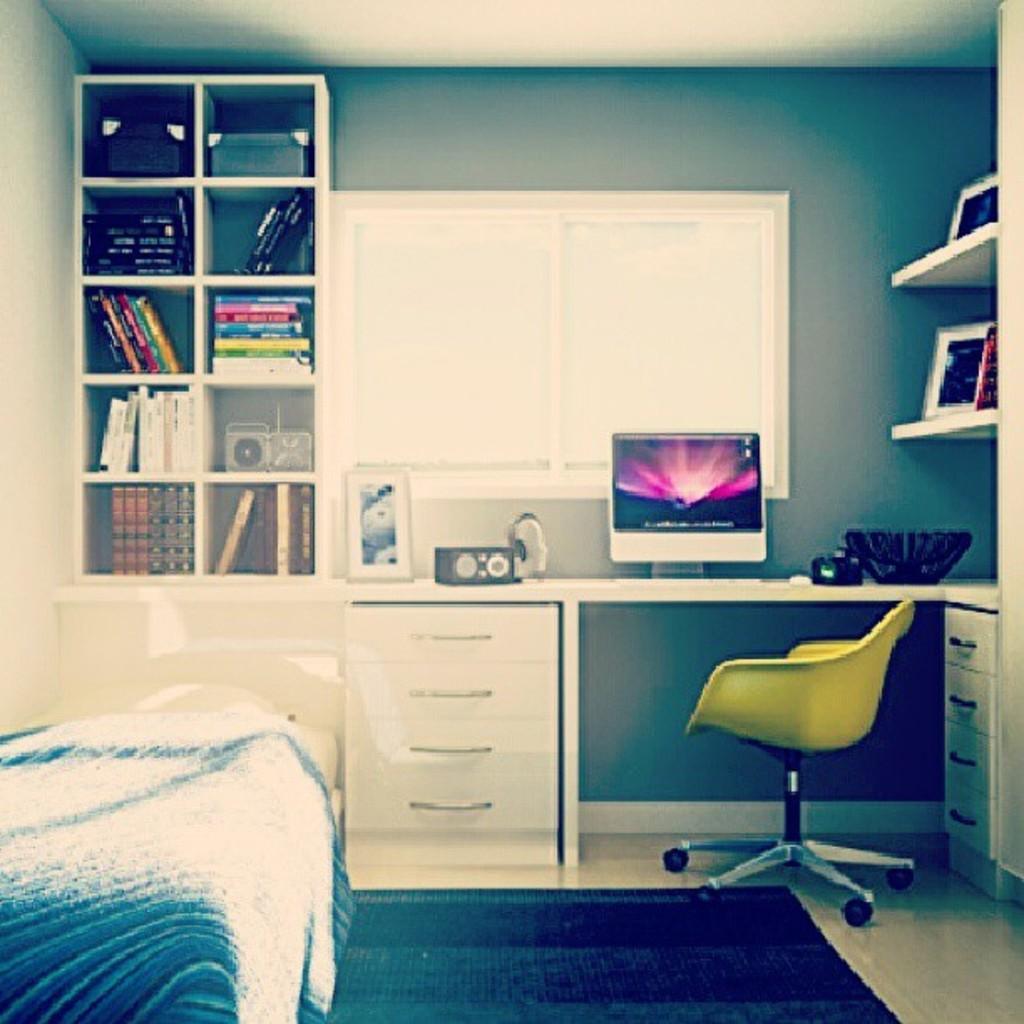Describe this image in one or two sentences. there is a room in which there is a yellow chair. at the table there is a white table on which there is a computer. at the left there is a shelf in which there are books and boxes. at the center there is a window. at the right there is a shelf. there is a bed in the left front. 